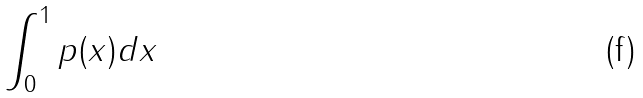Convert formula to latex. <formula><loc_0><loc_0><loc_500><loc_500>\int _ { 0 } ^ { 1 } p ( x ) d x</formula> 